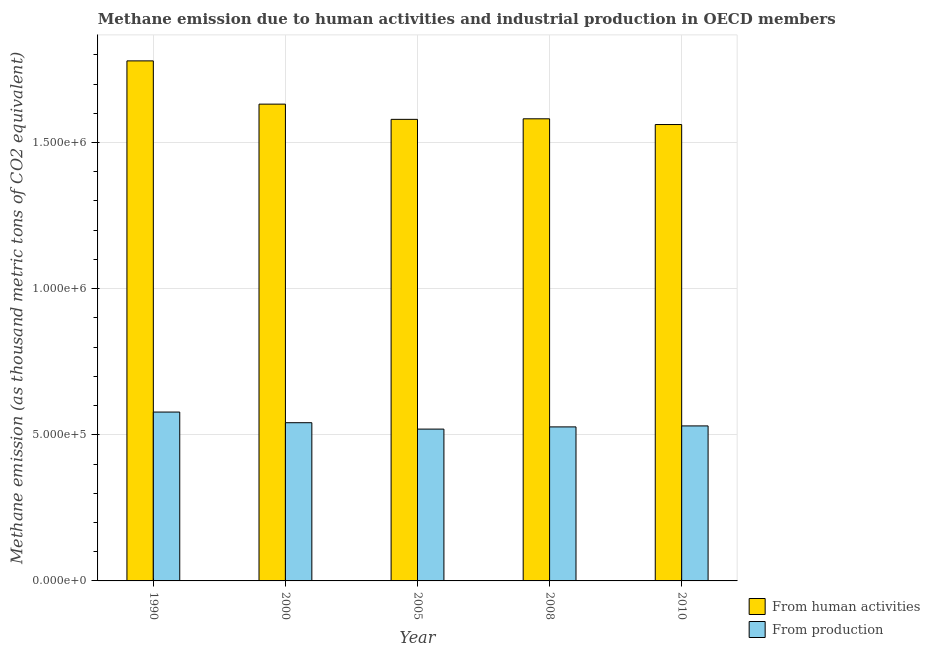How many different coloured bars are there?
Offer a terse response. 2. How many bars are there on the 2nd tick from the left?
Ensure brevity in your answer.  2. What is the label of the 2nd group of bars from the left?
Give a very brief answer. 2000. In how many cases, is the number of bars for a given year not equal to the number of legend labels?
Your answer should be very brief. 0. What is the amount of emissions from human activities in 2008?
Make the answer very short. 1.58e+06. Across all years, what is the maximum amount of emissions generated from industries?
Your response must be concise. 5.78e+05. Across all years, what is the minimum amount of emissions generated from industries?
Your answer should be very brief. 5.19e+05. In which year was the amount of emissions from human activities maximum?
Your answer should be very brief. 1990. In which year was the amount of emissions from human activities minimum?
Provide a short and direct response. 2010. What is the total amount of emissions from human activities in the graph?
Your answer should be compact. 8.13e+06. What is the difference between the amount of emissions from human activities in 1990 and that in 2005?
Make the answer very short. 2.00e+05. What is the difference between the amount of emissions generated from industries in 2000 and the amount of emissions from human activities in 2008?
Your response must be concise. 1.43e+04. What is the average amount of emissions from human activities per year?
Give a very brief answer. 1.63e+06. What is the ratio of the amount of emissions generated from industries in 2005 to that in 2008?
Keep it short and to the point. 0.99. Is the difference between the amount of emissions generated from industries in 1990 and 2005 greater than the difference between the amount of emissions from human activities in 1990 and 2005?
Keep it short and to the point. No. What is the difference between the highest and the second highest amount of emissions generated from industries?
Offer a terse response. 3.65e+04. What is the difference between the highest and the lowest amount of emissions from human activities?
Provide a succinct answer. 2.18e+05. Is the sum of the amount of emissions from human activities in 2005 and 2010 greater than the maximum amount of emissions generated from industries across all years?
Offer a terse response. Yes. What does the 2nd bar from the left in 1990 represents?
Your response must be concise. From production. What does the 1st bar from the right in 2005 represents?
Make the answer very short. From production. How many years are there in the graph?
Your answer should be compact. 5. What is the title of the graph?
Provide a succinct answer. Methane emission due to human activities and industrial production in OECD members. What is the label or title of the X-axis?
Ensure brevity in your answer.  Year. What is the label or title of the Y-axis?
Your answer should be compact. Methane emission (as thousand metric tons of CO2 equivalent). What is the Methane emission (as thousand metric tons of CO2 equivalent) in From human activities in 1990?
Give a very brief answer. 1.78e+06. What is the Methane emission (as thousand metric tons of CO2 equivalent) in From production in 1990?
Make the answer very short. 5.78e+05. What is the Methane emission (as thousand metric tons of CO2 equivalent) in From human activities in 2000?
Make the answer very short. 1.63e+06. What is the Methane emission (as thousand metric tons of CO2 equivalent) of From production in 2000?
Your response must be concise. 5.41e+05. What is the Methane emission (as thousand metric tons of CO2 equivalent) of From human activities in 2005?
Offer a terse response. 1.58e+06. What is the Methane emission (as thousand metric tons of CO2 equivalent) of From production in 2005?
Ensure brevity in your answer.  5.19e+05. What is the Methane emission (as thousand metric tons of CO2 equivalent) in From human activities in 2008?
Provide a succinct answer. 1.58e+06. What is the Methane emission (as thousand metric tons of CO2 equivalent) of From production in 2008?
Offer a terse response. 5.27e+05. What is the Methane emission (as thousand metric tons of CO2 equivalent) in From human activities in 2010?
Offer a very short reply. 1.56e+06. What is the Methane emission (as thousand metric tons of CO2 equivalent) of From production in 2010?
Provide a short and direct response. 5.30e+05. Across all years, what is the maximum Methane emission (as thousand metric tons of CO2 equivalent) in From human activities?
Your answer should be very brief. 1.78e+06. Across all years, what is the maximum Methane emission (as thousand metric tons of CO2 equivalent) in From production?
Your response must be concise. 5.78e+05. Across all years, what is the minimum Methane emission (as thousand metric tons of CO2 equivalent) in From human activities?
Provide a short and direct response. 1.56e+06. Across all years, what is the minimum Methane emission (as thousand metric tons of CO2 equivalent) of From production?
Your answer should be very brief. 5.19e+05. What is the total Methane emission (as thousand metric tons of CO2 equivalent) of From human activities in the graph?
Keep it short and to the point. 8.13e+06. What is the total Methane emission (as thousand metric tons of CO2 equivalent) in From production in the graph?
Keep it short and to the point. 2.70e+06. What is the difference between the Methane emission (as thousand metric tons of CO2 equivalent) of From human activities in 1990 and that in 2000?
Give a very brief answer. 1.48e+05. What is the difference between the Methane emission (as thousand metric tons of CO2 equivalent) of From production in 1990 and that in 2000?
Offer a very short reply. 3.65e+04. What is the difference between the Methane emission (as thousand metric tons of CO2 equivalent) of From human activities in 1990 and that in 2005?
Your answer should be very brief. 2.00e+05. What is the difference between the Methane emission (as thousand metric tons of CO2 equivalent) in From production in 1990 and that in 2005?
Ensure brevity in your answer.  5.83e+04. What is the difference between the Methane emission (as thousand metric tons of CO2 equivalent) in From human activities in 1990 and that in 2008?
Provide a short and direct response. 1.98e+05. What is the difference between the Methane emission (as thousand metric tons of CO2 equivalent) in From production in 1990 and that in 2008?
Keep it short and to the point. 5.08e+04. What is the difference between the Methane emission (as thousand metric tons of CO2 equivalent) in From human activities in 1990 and that in 2010?
Make the answer very short. 2.18e+05. What is the difference between the Methane emission (as thousand metric tons of CO2 equivalent) in From production in 1990 and that in 2010?
Your response must be concise. 4.74e+04. What is the difference between the Methane emission (as thousand metric tons of CO2 equivalent) of From human activities in 2000 and that in 2005?
Make the answer very short. 5.21e+04. What is the difference between the Methane emission (as thousand metric tons of CO2 equivalent) in From production in 2000 and that in 2005?
Your answer should be very brief. 2.19e+04. What is the difference between the Methane emission (as thousand metric tons of CO2 equivalent) of From human activities in 2000 and that in 2008?
Your answer should be very brief. 5.02e+04. What is the difference between the Methane emission (as thousand metric tons of CO2 equivalent) in From production in 2000 and that in 2008?
Keep it short and to the point. 1.43e+04. What is the difference between the Methane emission (as thousand metric tons of CO2 equivalent) in From human activities in 2000 and that in 2010?
Your answer should be compact. 6.98e+04. What is the difference between the Methane emission (as thousand metric tons of CO2 equivalent) in From production in 2000 and that in 2010?
Make the answer very short. 1.09e+04. What is the difference between the Methane emission (as thousand metric tons of CO2 equivalent) of From human activities in 2005 and that in 2008?
Your answer should be very brief. -1871.6. What is the difference between the Methane emission (as thousand metric tons of CO2 equivalent) of From production in 2005 and that in 2008?
Make the answer very short. -7540.4. What is the difference between the Methane emission (as thousand metric tons of CO2 equivalent) in From human activities in 2005 and that in 2010?
Make the answer very short. 1.77e+04. What is the difference between the Methane emission (as thousand metric tons of CO2 equivalent) of From production in 2005 and that in 2010?
Offer a terse response. -1.09e+04. What is the difference between the Methane emission (as thousand metric tons of CO2 equivalent) in From human activities in 2008 and that in 2010?
Offer a very short reply. 1.96e+04. What is the difference between the Methane emission (as thousand metric tons of CO2 equivalent) of From production in 2008 and that in 2010?
Keep it short and to the point. -3406. What is the difference between the Methane emission (as thousand metric tons of CO2 equivalent) of From human activities in 1990 and the Methane emission (as thousand metric tons of CO2 equivalent) of From production in 2000?
Provide a short and direct response. 1.24e+06. What is the difference between the Methane emission (as thousand metric tons of CO2 equivalent) of From human activities in 1990 and the Methane emission (as thousand metric tons of CO2 equivalent) of From production in 2005?
Your answer should be compact. 1.26e+06. What is the difference between the Methane emission (as thousand metric tons of CO2 equivalent) of From human activities in 1990 and the Methane emission (as thousand metric tons of CO2 equivalent) of From production in 2008?
Provide a succinct answer. 1.25e+06. What is the difference between the Methane emission (as thousand metric tons of CO2 equivalent) in From human activities in 1990 and the Methane emission (as thousand metric tons of CO2 equivalent) in From production in 2010?
Your response must be concise. 1.25e+06. What is the difference between the Methane emission (as thousand metric tons of CO2 equivalent) in From human activities in 2000 and the Methane emission (as thousand metric tons of CO2 equivalent) in From production in 2005?
Your response must be concise. 1.11e+06. What is the difference between the Methane emission (as thousand metric tons of CO2 equivalent) in From human activities in 2000 and the Methane emission (as thousand metric tons of CO2 equivalent) in From production in 2008?
Provide a short and direct response. 1.10e+06. What is the difference between the Methane emission (as thousand metric tons of CO2 equivalent) of From human activities in 2000 and the Methane emission (as thousand metric tons of CO2 equivalent) of From production in 2010?
Give a very brief answer. 1.10e+06. What is the difference between the Methane emission (as thousand metric tons of CO2 equivalent) of From human activities in 2005 and the Methane emission (as thousand metric tons of CO2 equivalent) of From production in 2008?
Offer a very short reply. 1.05e+06. What is the difference between the Methane emission (as thousand metric tons of CO2 equivalent) in From human activities in 2005 and the Methane emission (as thousand metric tons of CO2 equivalent) in From production in 2010?
Your answer should be compact. 1.05e+06. What is the difference between the Methane emission (as thousand metric tons of CO2 equivalent) in From human activities in 2008 and the Methane emission (as thousand metric tons of CO2 equivalent) in From production in 2010?
Ensure brevity in your answer.  1.05e+06. What is the average Methane emission (as thousand metric tons of CO2 equivalent) of From human activities per year?
Keep it short and to the point. 1.63e+06. What is the average Methane emission (as thousand metric tons of CO2 equivalent) in From production per year?
Offer a very short reply. 5.39e+05. In the year 1990, what is the difference between the Methane emission (as thousand metric tons of CO2 equivalent) in From human activities and Methane emission (as thousand metric tons of CO2 equivalent) in From production?
Your answer should be very brief. 1.20e+06. In the year 2000, what is the difference between the Methane emission (as thousand metric tons of CO2 equivalent) in From human activities and Methane emission (as thousand metric tons of CO2 equivalent) in From production?
Your answer should be compact. 1.09e+06. In the year 2005, what is the difference between the Methane emission (as thousand metric tons of CO2 equivalent) in From human activities and Methane emission (as thousand metric tons of CO2 equivalent) in From production?
Give a very brief answer. 1.06e+06. In the year 2008, what is the difference between the Methane emission (as thousand metric tons of CO2 equivalent) of From human activities and Methane emission (as thousand metric tons of CO2 equivalent) of From production?
Your answer should be very brief. 1.05e+06. In the year 2010, what is the difference between the Methane emission (as thousand metric tons of CO2 equivalent) of From human activities and Methane emission (as thousand metric tons of CO2 equivalent) of From production?
Give a very brief answer. 1.03e+06. What is the ratio of the Methane emission (as thousand metric tons of CO2 equivalent) in From human activities in 1990 to that in 2000?
Give a very brief answer. 1.09. What is the ratio of the Methane emission (as thousand metric tons of CO2 equivalent) of From production in 1990 to that in 2000?
Give a very brief answer. 1.07. What is the ratio of the Methane emission (as thousand metric tons of CO2 equivalent) in From human activities in 1990 to that in 2005?
Provide a short and direct response. 1.13. What is the ratio of the Methane emission (as thousand metric tons of CO2 equivalent) of From production in 1990 to that in 2005?
Give a very brief answer. 1.11. What is the ratio of the Methane emission (as thousand metric tons of CO2 equivalent) in From human activities in 1990 to that in 2008?
Ensure brevity in your answer.  1.13. What is the ratio of the Methane emission (as thousand metric tons of CO2 equivalent) in From production in 1990 to that in 2008?
Your response must be concise. 1.1. What is the ratio of the Methane emission (as thousand metric tons of CO2 equivalent) of From human activities in 1990 to that in 2010?
Your answer should be compact. 1.14. What is the ratio of the Methane emission (as thousand metric tons of CO2 equivalent) of From production in 1990 to that in 2010?
Provide a short and direct response. 1.09. What is the ratio of the Methane emission (as thousand metric tons of CO2 equivalent) of From human activities in 2000 to that in 2005?
Make the answer very short. 1.03. What is the ratio of the Methane emission (as thousand metric tons of CO2 equivalent) in From production in 2000 to that in 2005?
Provide a short and direct response. 1.04. What is the ratio of the Methane emission (as thousand metric tons of CO2 equivalent) in From human activities in 2000 to that in 2008?
Offer a terse response. 1.03. What is the ratio of the Methane emission (as thousand metric tons of CO2 equivalent) in From production in 2000 to that in 2008?
Make the answer very short. 1.03. What is the ratio of the Methane emission (as thousand metric tons of CO2 equivalent) of From human activities in 2000 to that in 2010?
Your response must be concise. 1.04. What is the ratio of the Methane emission (as thousand metric tons of CO2 equivalent) of From production in 2000 to that in 2010?
Keep it short and to the point. 1.02. What is the ratio of the Methane emission (as thousand metric tons of CO2 equivalent) in From human activities in 2005 to that in 2008?
Keep it short and to the point. 1. What is the ratio of the Methane emission (as thousand metric tons of CO2 equivalent) in From production in 2005 to that in 2008?
Your answer should be compact. 0.99. What is the ratio of the Methane emission (as thousand metric tons of CO2 equivalent) in From human activities in 2005 to that in 2010?
Ensure brevity in your answer.  1.01. What is the ratio of the Methane emission (as thousand metric tons of CO2 equivalent) in From production in 2005 to that in 2010?
Offer a very short reply. 0.98. What is the ratio of the Methane emission (as thousand metric tons of CO2 equivalent) in From human activities in 2008 to that in 2010?
Your answer should be very brief. 1.01. What is the ratio of the Methane emission (as thousand metric tons of CO2 equivalent) of From production in 2008 to that in 2010?
Offer a terse response. 0.99. What is the difference between the highest and the second highest Methane emission (as thousand metric tons of CO2 equivalent) of From human activities?
Offer a very short reply. 1.48e+05. What is the difference between the highest and the second highest Methane emission (as thousand metric tons of CO2 equivalent) in From production?
Keep it short and to the point. 3.65e+04. What is the difference between the highest and the lowest Methane emission (as thousand metric tons of CO2 equivalent) in From human activities?
Keep it short and to the point. 2.18e+05. What is the difference between the highest and the lowest Methane emission (as thousand metric tons of CO2 equivalent) of From production?
Offer a terse response. 5.83e+04. 